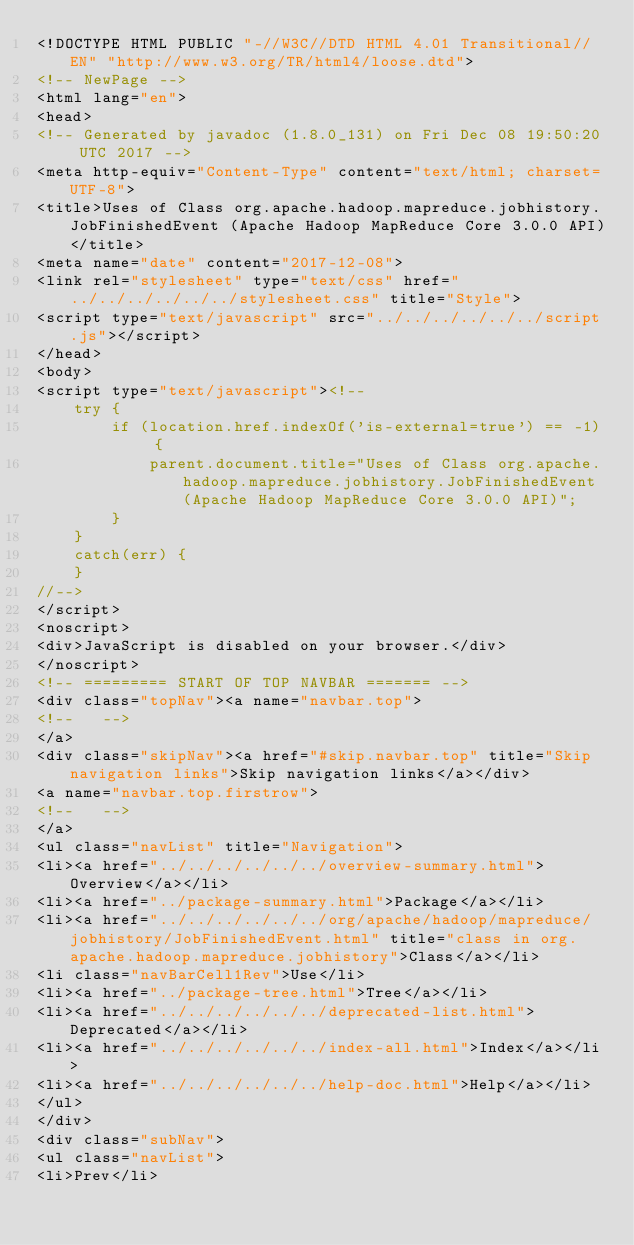Convert code to text. <code><loc_0><loc_0><loc_500><loc_500><_HTML_><!DOCTYPE HTML PUBLIC "-//W3C//DTD HTML 4.01 Transitional//EN" "http://www.w3.org/TR/html4/loose.dtd">
<!-- NewPage -->
<html lang="en">
<head>
<!-- Generated by javadoc (1.8.0_131) on Fri Dec 08 19:50:20 UTC 2017 -->
<meta http-equiv="Content-Type" content="text/html; charset=UTF-8">
<title>Uses of Class org.apache.hadoop.mapreduce.jobhistory.JobFinishedEvent (Apache Hadoop MapReduce Core 3.0.0 API)</title>
<meta name="date" content="2017-12-08">
<link rel="stylesheet" type="text/css" href="../../../../../../stylesheet.css" title="Style">
<script type="text/javascript" src="../../../../../../script.js"></script>
</head>
<body>
<script type="text/javascript"><!--
    try {
        if (location.href.indexOf('is-external=true') == -1) {
            parent.document.title="Uses of Class org.apache.hadoop.mapreduce.jobhistory.JobFinishedEvent (Apache Hadoop MapReduce Core 3.0.0 API)";
        }
    }
    catch(err) {
    }
//-->
</script>
<noscript>
<div>JavaScript is disabled on your browser.</div>
</noscript>
<!-- ========= START OF TOP NAVBAR ======= -->
<div class="topNav"><a name="navbar.top">
<!--   -->
</a>
<div class="skipNav"><a href="#skip.navbar.top" title="Skip navigation links">Skip navigation links</a></div>
<a name="navbar.top.firstrow">
<!--   -->
</a>
<ul class="navList" title="Navigation">
<li><a href="../../../../../../overview-summary.html">Overview</a></li>
<li><a href="../package-summary.html">Package</a></li>
<li><a href="../../../../../../org/apache/hadoop/mapreduce/jobhistory/JobFinishedEvent.html" title="class in org.apache.hadoop.mapreduce.jobhistory">Class</a></li>
<li class="navBarCell1Rev">Use</li>
<li><a href="../package-tree.html">Tree</a></li>
<li><a href="../../../../../../deprecated-list.html">Deprecated</a></li>
<li><a href="../../../../../../index-all.html">Index</a></li>
<li><a href="../../../../../../help-doc.html">Help</a></li>
</ul>
</div>
<div class="subNav">
<ul class="navList">
<li>Prev</li></code> 